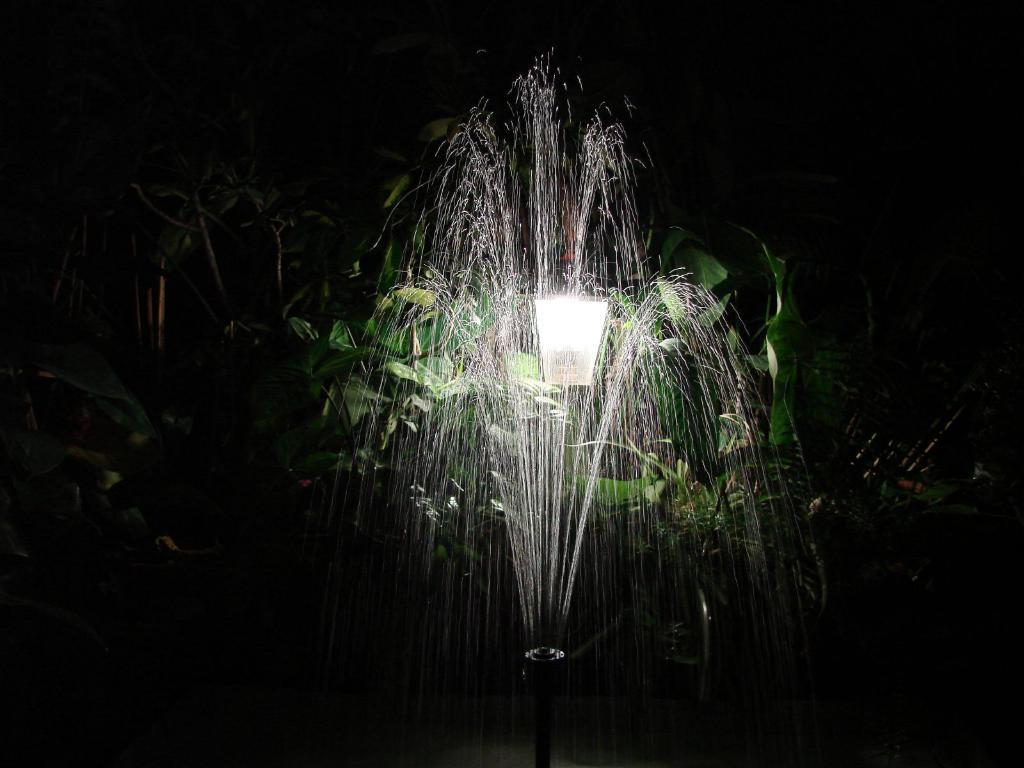What is the main feature in the image? There is a water fountain in the image. Where is the water fountain located? The water fountain is in the front of the image. What can be seen in the background of the image? There is a light shade and plants in the background of the image. What type of insect is crawling on the water fountain in the image? There are no insects present on the water fountain in the image. 